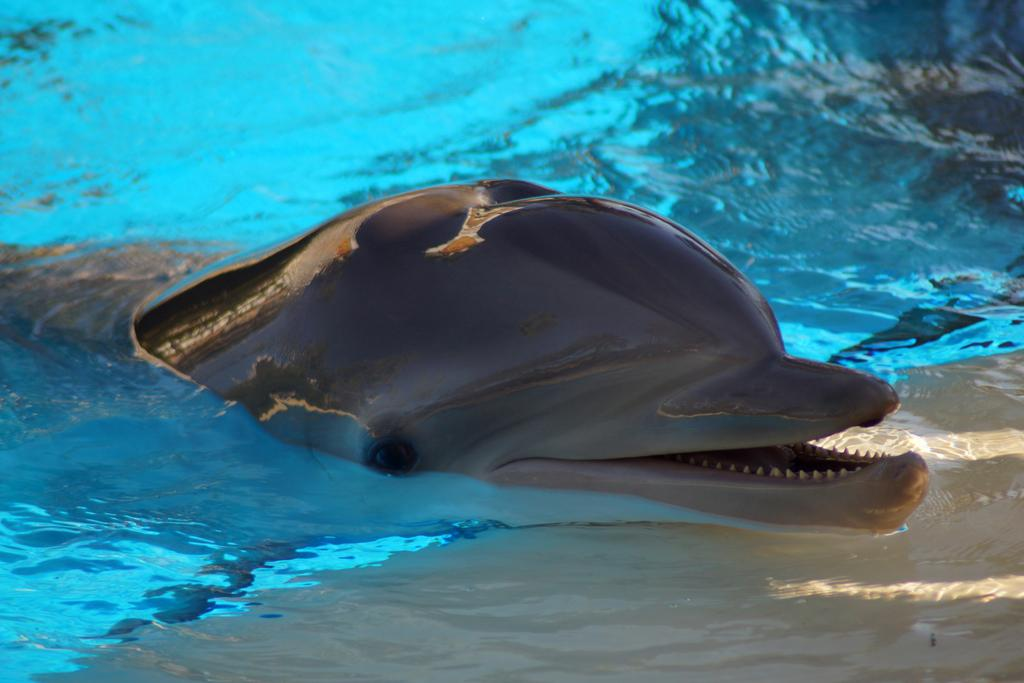What animal is in the image? There is a dolphin in the image. Where is the dolphin located? The dolphin is in the water. What type of sack is being used to carry the dolphin in the image? There is no sack present in the image, as the dolphin is in the water. 